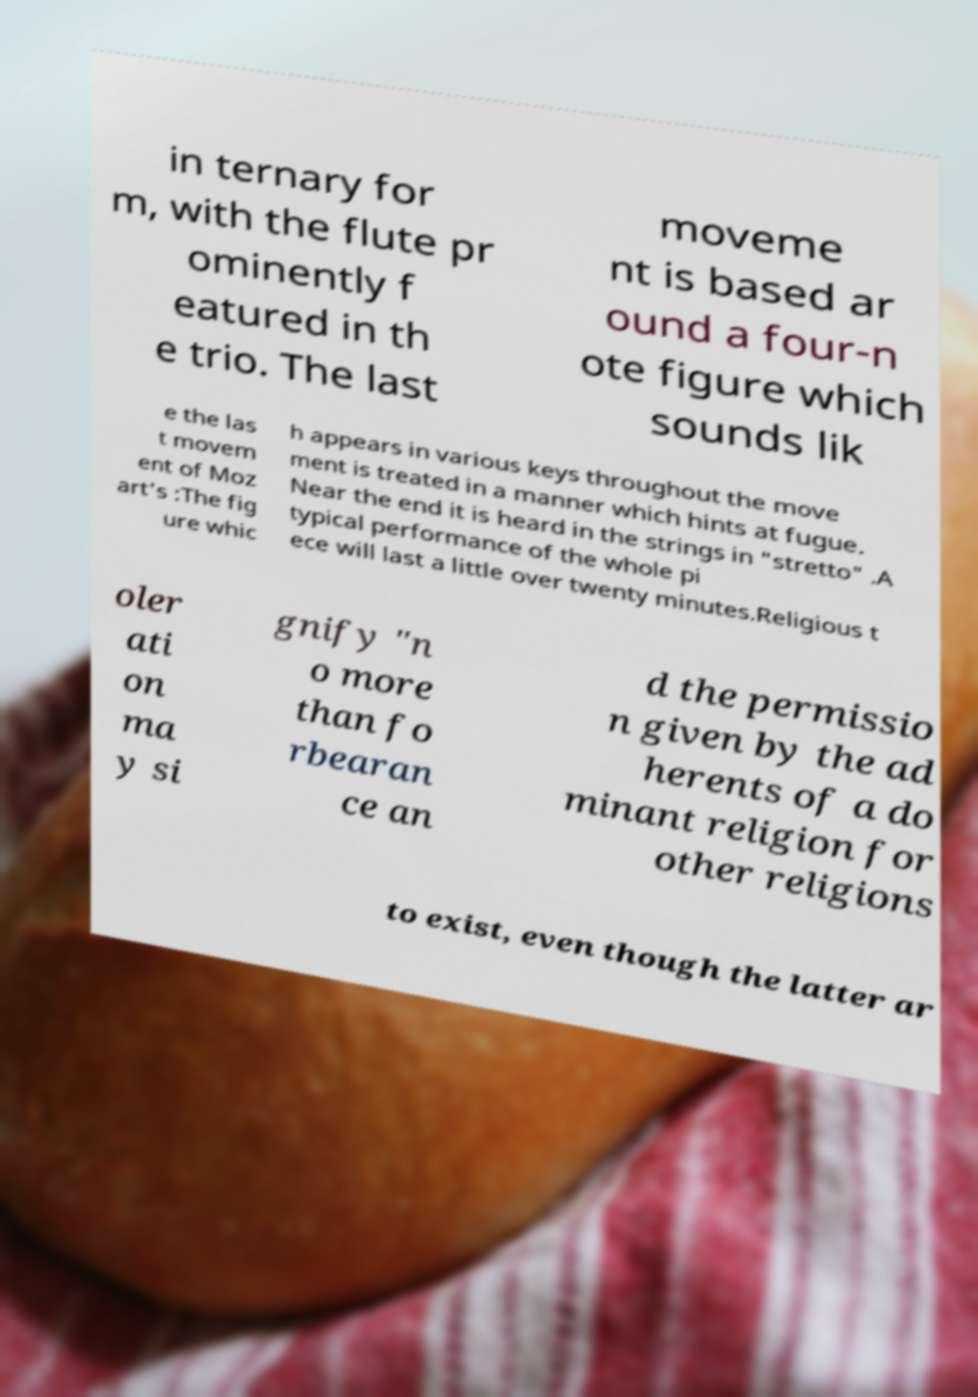Can you accurately transcribe the text from the provided image for me? in ternary for m, with the flute pr ominently f eatured in th e trio. The last moveme nt is based ar ound a four-n ote figure which sounds lik e the las t movem ent of Moz art's :The fig ure whic h appears in various keys throughout the move ment is treated in a manner which hints at fugue. Near the end it is heard in the strings in "stretto" .A typical performance of the whole pi ece will last a little over twenty minutes.Religious t oler ati on ma y si gnify "n o more than fo rbearan ce an d the permissio n given by the ad herents of a do minant religion for other religions to exist, even though the latter ar 